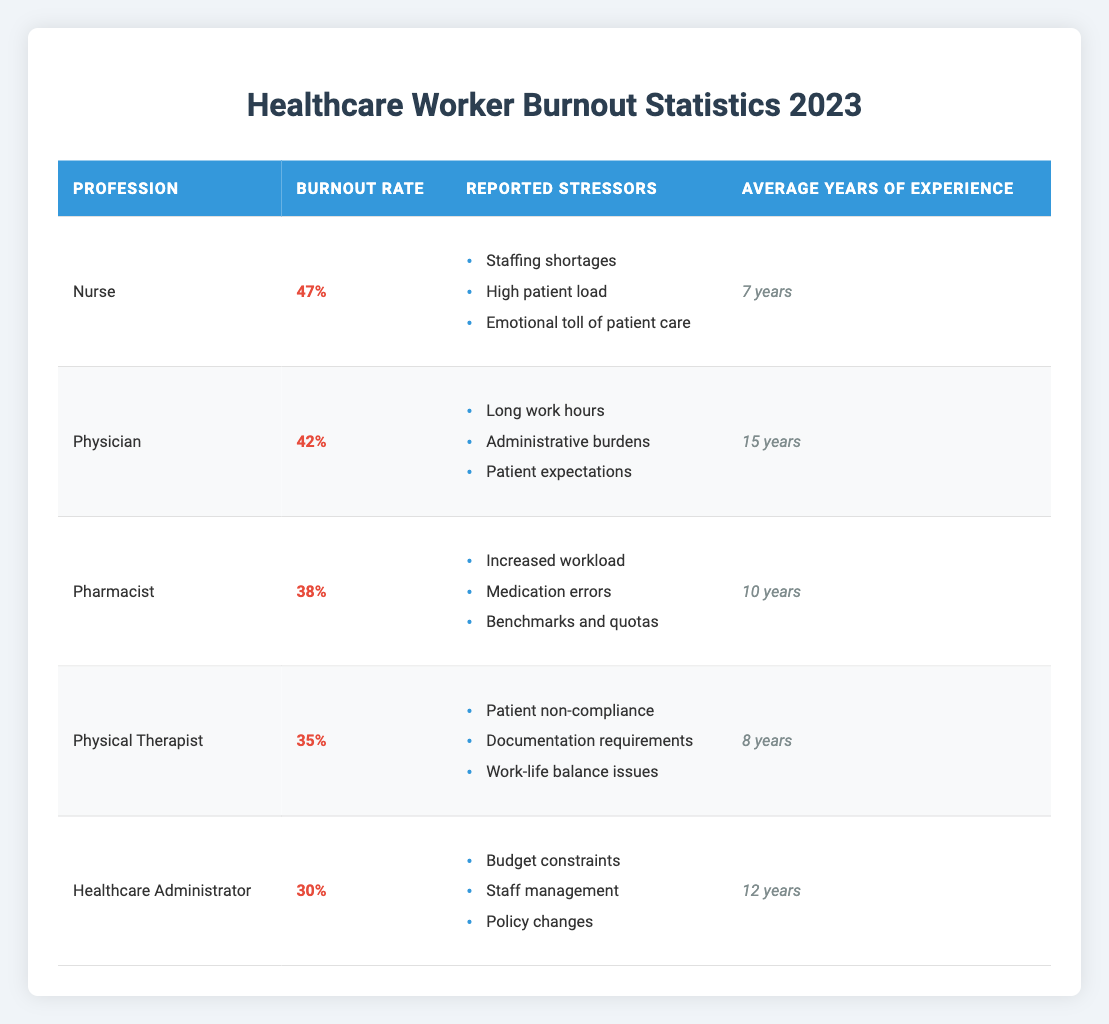What is the burnout rate for Nurses? The table indicates that the burnout rate for Nurses is listed directly as 47%.
Answer: 47% Which profession has the highest burnout rate? By comparing the burnout rates listed in the table, Nurses have the highest rate at 47%.
Answer: Nurses What are the reported stressors for Physicians? The table lists the reported stressors for Physicians as long work hours, administrative burdens, and patient expectations.
Answer: Long work hours, administrative burdens, patient expectations What is the average burnout rate among all professions listed? To calculate the average, add the burnout rates (47 + 42 + 38 + 35 + 30 = 192) and divide by the number of professions (192 / 5 = 38.4).
Answer: 38.4% Is the average years of experience for Pharmacists greater than for Physical Therapists? The average years of experience for Pharmacists is 10, while for Physical Therapists, it is 8. Thus, 10 > 8 is true.
Answer: Yes How many more percentage points is the burnout rate for Nurses compared to Healthcare Administrators? The difference in burnout rates is calculated as 47 (Nurses) - 30 (Healthcare Administrators) = 17.
Answer: 17 percentage points Which profession has the lowest burnout rate, and what is that rate? Identifying the lowest burnout rate, Healthcare Administrators have the lowest rate at 30%.
Answer: Healthcare Administrators, 30% What is the total average years of experience for all professionals listed? The total average is calculated by summing the years of experience (7 + 15 + 10 + 8 + 12 = 52) and dividing by the number of professions (52 / 5 = 10.4).
Answer: 10.4 years Are emotional tolls on patient care a reported stressor for Pharmacists? Referring to the stressors listed for Pharmacists, emotional tolls on patient care do not appear. Therefore, this statement is false.
Answer: No 